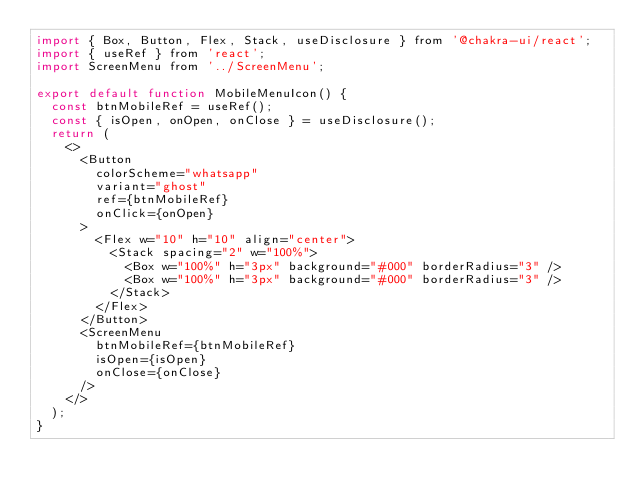<code> <loc_0><loc_0><loc_500><loc_500><_JavaScript_>import { Box, Button, Flex, Stack, useDisclosure } from '@chakra-ui/react';
import { useRef } from 'react';
import ScreenMenu from '../ScreenMenu';

export default function MobileMenuIcon() {
  const btnMobileRef = useRef();
  const { isOpen, onOpen, onClose } = useDisclosure();
  return (
    <>
      <Button
        colorScheme="whatsapp"
        variant="ghost"
        ref={btnMobileRef}
        onClick={onOpen}
      >
        <Flex w="10" h="10" align="center">
          <Stack spacing="2" w="100%">
            <Box w="100%" h="3px" background="#000" borderRadius="3" />
            <Box w="100%" h="3px" background="#000" borderRadius="3" />
          </Stack>
        </Flex>
      </Button>
      <ScreenMenu
        btnMobileRef={btnMobileRef}
        isOpen={isOpen}
        onClose={onClose}
      />
    </>
  );
}
</code> 